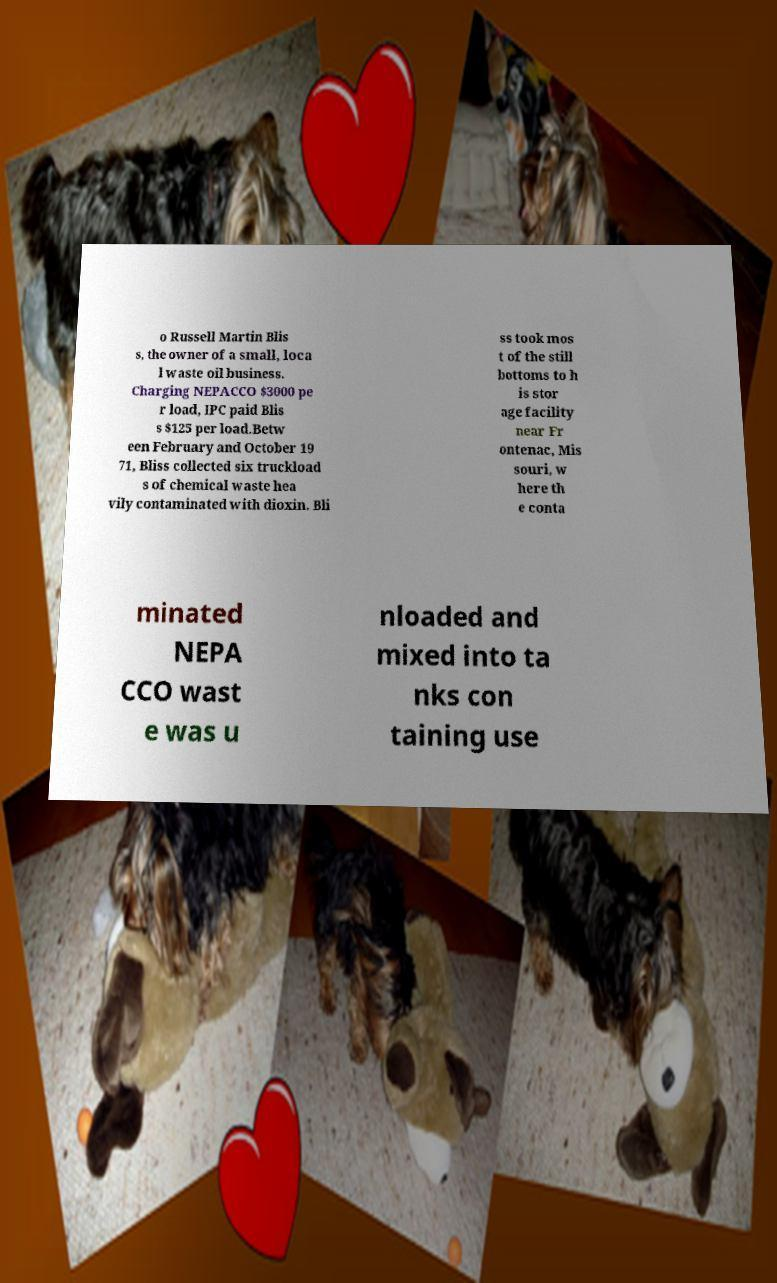There's text embedded in this image that I need extracted. Can you transcribe it verbatim? o Russell Martin Blis s, the owner of a small, loca l waste oil business. Charging NEPACCO $3000 pe r load, IPC paid Blis s $125 per load.Betw een February and October 19 71, Bliss collected six truckload s of chemical waste hea vily contaminated with dioxin. Bli ss took mos t of the still bottoms to h is stor age facility near Fr ontenac, Mis souri, w here th e conta minated NEPA CCO wast e was u nloaded and mixed into ta nks con taining use 